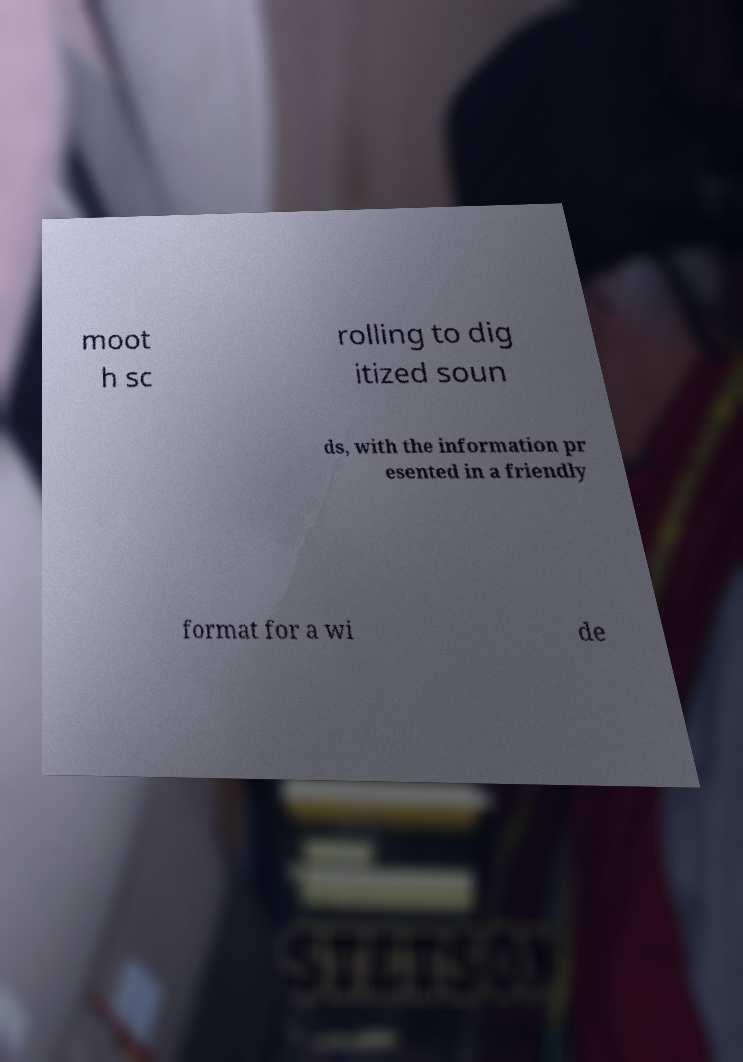Can you accurately transcribe the text from the provided image for me? moot h sc rolling to dig itized soun ds, with the information pr esented in a friendly format for a wi de 